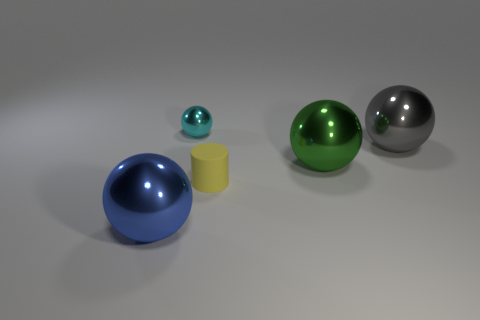There is a metal thing that is both in front of the gray sphere and to the right of the small yellow cylinder; how big is it?
Ensure brevity in your answer.  Large. Are there any tiny brown blocks made of the same material as the blue object?
Your answer should be very brief. No. There is a thing that is to the left of the small cyan sphere that is behind the green metal ball; what is it made of?
Offer a very short reply. Metal. What size is the gray ball that is the same material as the green sphere?
Your answer should be very brief. Large. What shape is the big metallic object on the left side of the small yellow matte cylinder?
Your answer should be compact. Sphere. What size is the green thing that is the same shape as the cyan metal thing?
Give a very brief answer. Large. There is a large sphere in front of the small thing that is in front of the cyan thing; what number of yellow matte cylinders are left of it?
Provide a short and direct response. 0. Is the number of green shiny things that are behind the green shiny sphere the same as the number of big gray metal spheres?
Ensure brevity in your answer.  No. How many balls are metallic things or large cyan things?
Keep it short and to the point. 4. Is the tiny matte object the same color as the tiny sphere?
Keep it short and to the point. No. 